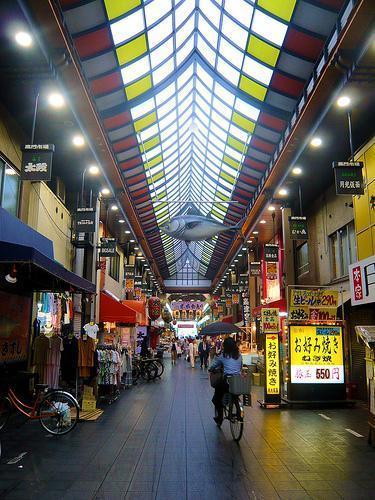How many fishes hanging on the ceiling?
Give a very brief answer. 1. 